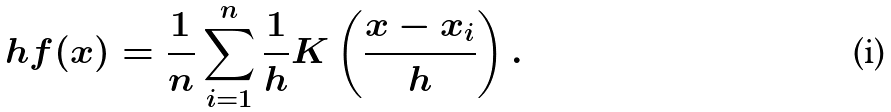Convert formula to latex. <formula><loc_0><loc_0><loc_500><loc_500>\ h f ( x ) = \frac { 1 } { n } \sum _ { i = 1 } ^ { n } \frac { 1 } { h } K \left ( \frac { x - x _ { i } } { h } \right ) .</formula> 